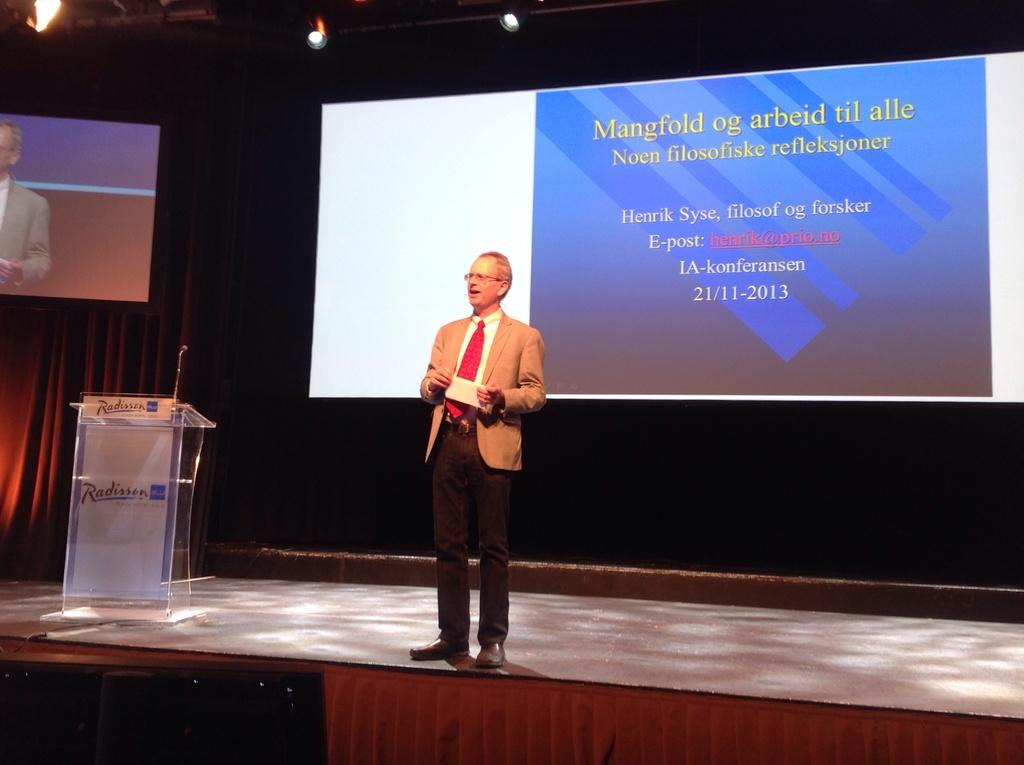What year is on the presentation?
Offer a terse response. 2013. 